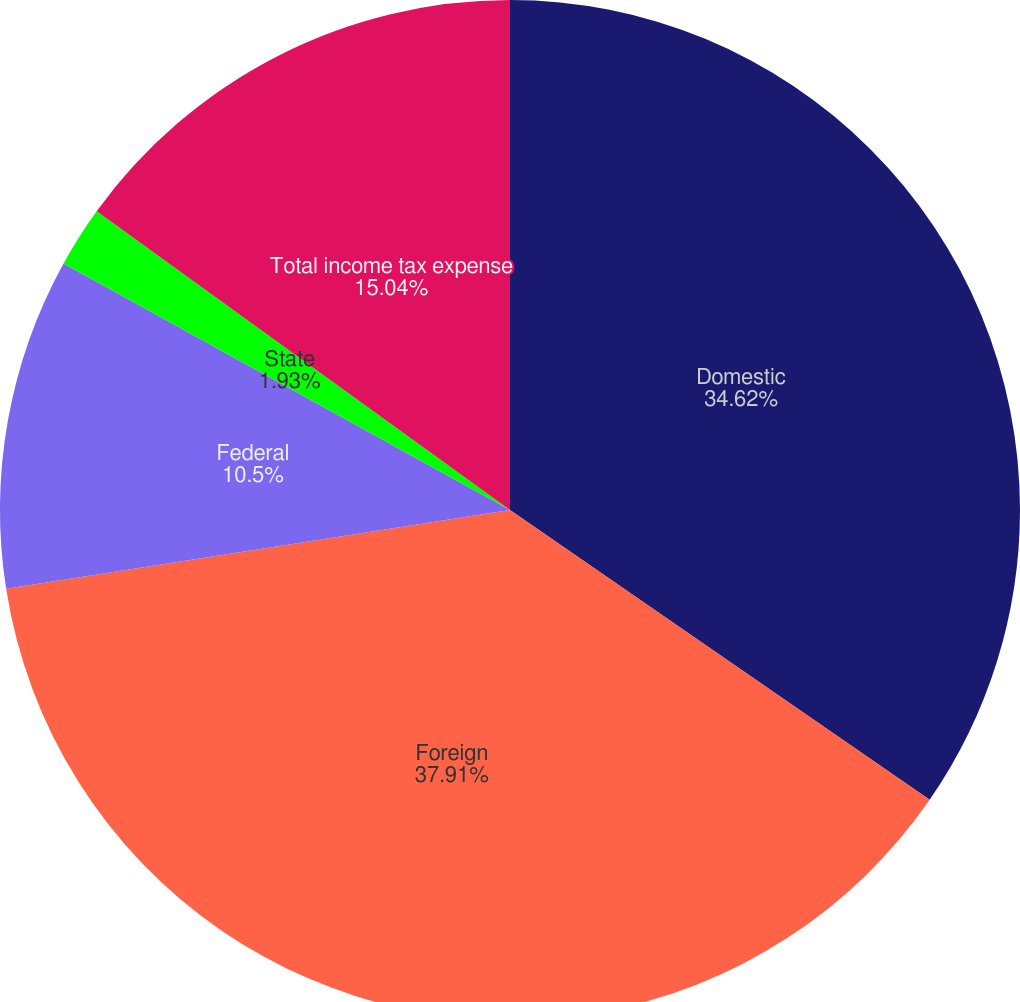<chart> <loc_0><loc_0><loc_500><loc_500><pie_chart><fcel>Domestic<fcel>Foreign<fcel>Federal<fcel>State<fcel>Total income tax expense<nl><fcel>34.62%<fcel>37.91%<fcel>10.5%<fcel>1.93%<fcel>15.04%<nl></chart> 